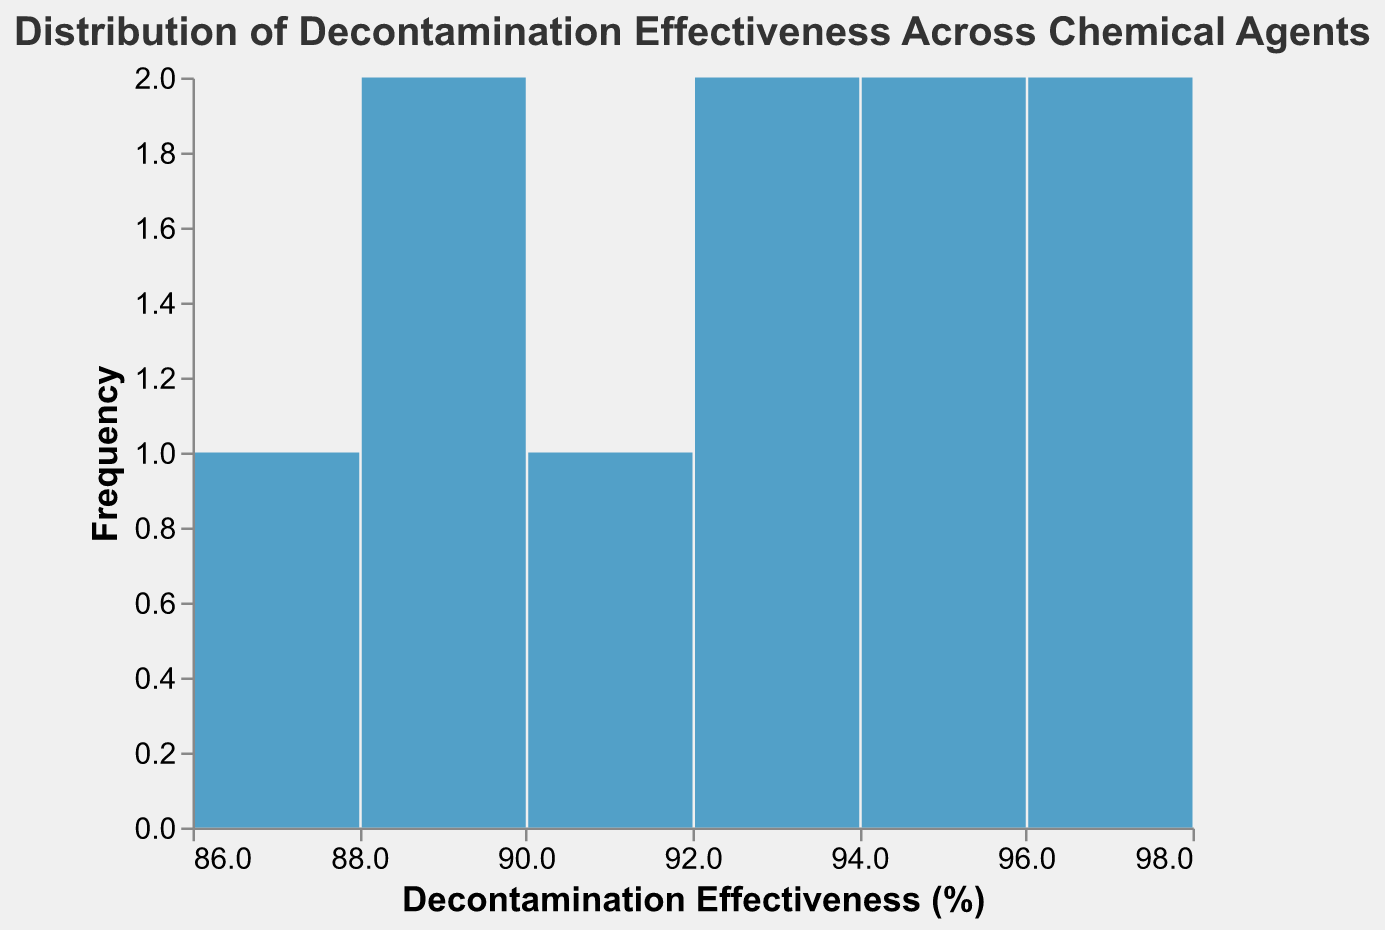What is the title of the figure? The title can be found directly at the top of the figure. It is usually presented in a slightly larger font compared to other text elements in the figure.
Answer: Distribution of Decontamination Effectiveness Across Chemical Agents What is the range of the x-axis? The x-axis represents "Decontamination Effectiveness (%)". By looking at the axis labels, we can determine the range.
Answer: 87-98% How many chemical agents are included in the data? Every bar in the histogram corresponds to one chemical agent. By counting the bars or looking at the data on the axis, we can determine the number of chemical agents.
Answer: 10 Which chemical agent has the highest decontamination effectiveness? To determine which chemical agent has the highest effectiveness, we look for the highest value on the x-axis.
Answer: Chlorine How many chemical agents have a decontamination effectiveness in the range 90-94%? To find how many agents fall within this range, we look at the bars that correspond to this interval on the x-axis.
Answer: 4 What is the frequency of the most common decontamination effectiveness range? The height of each bar represents the frequency. The tallest bar indicates the most common range.
Answer: 1 What is the average decontamination effectiveness across all chemical agents? Sum all the effectiveness values and then divide by the number of chemical agents: (95 + 92 + 88 + 98 + 93 + 97 + 89 + 94 + 91 + 87) / 10 = 92.4
Answer: 92.4% What is the decontamination effectiveness range with the least number of chemical agents? Look for the bar(s) with the smallest height on the histogram to find the least frequent effectiveness range.
Answer: Each range has 1 agent Are there any chemical agents with the same decontamination effectiveness? Check if any bars align vertically or look at the data values to see if any are identical.
Answer: No What is the difference between the highest and lowest decontamination effectiveness? Subtract the lowest value from the highest value observed on the histogram: 98 - 87
Answer: 11 